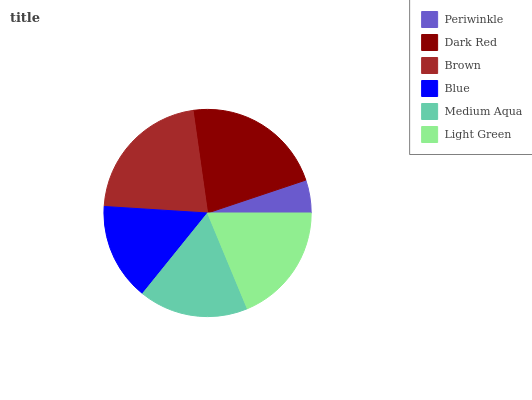Is Periwinkle the minimum?
Answer yes or no. Yes. Is Dark Red the maximum?
Answer yes or no. Yes. Is Brown the minimum?
Answer yes or no. No. Is Brown the maximum?
Answer yes or no. No. Is Dark Red greater than Brown?
Answer yes or no. Yes. Is Brown less than Dark Red?
Answer yes or no. Yes. Is Brown greater than Dark Red?
Answer yes or no. No. Is Dark Red less than Brown?
Answer yes or no. No. Is Light Green the high median?
Answer yes or no. Yes. Is Medium Aqua the low median?
Answer yes or no. Yes. Is Blue the high median?
Answer yes or no. No. Is Light Green the low median?
Answer yes or no. No. 